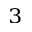<formula> <loc_0><loc_0><loc_500><loc_500>^ { 3 }</formula> 